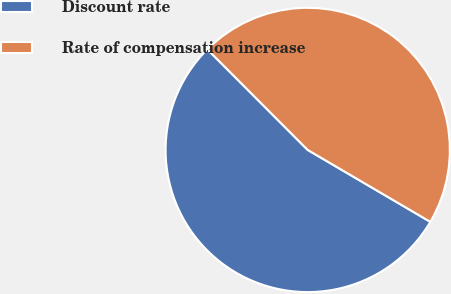Convert chart to OTSL. <chart><loc_0><loc_0><loc_500><loc_500><pie_chart><fcel>Discount rate<fcel>Rate of compensation increase<nl><fcel>54.08%<fcel>45.92%<nl></chart> 